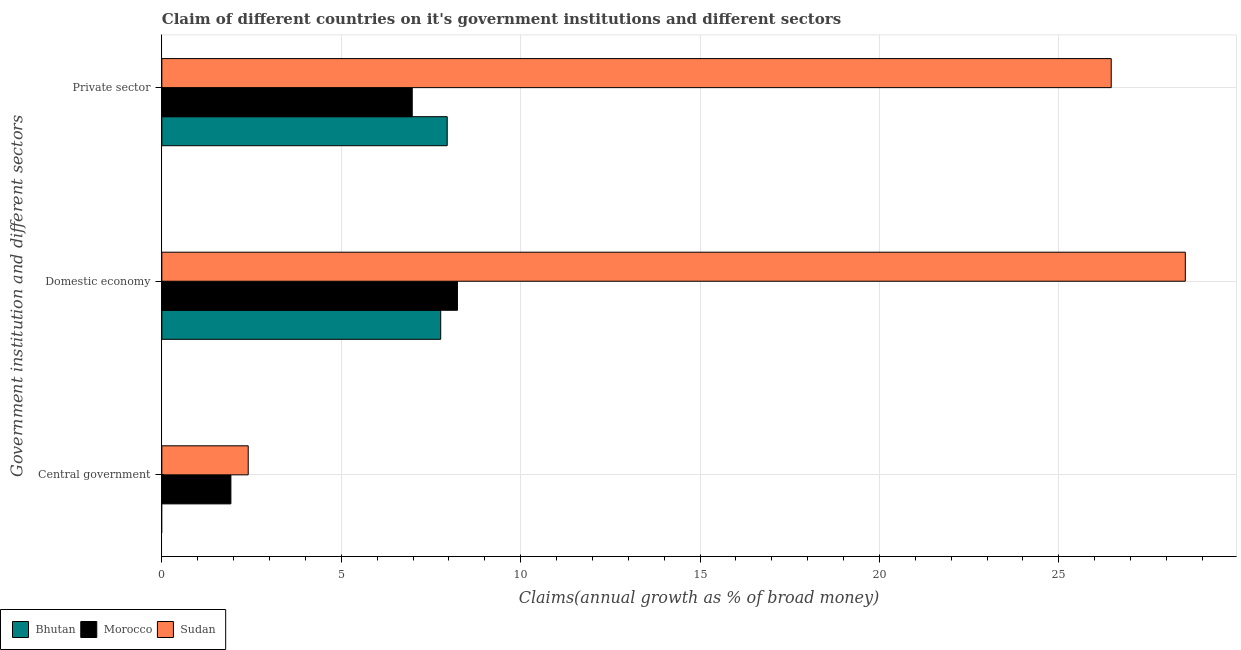Are the number of bars per tick equal to the number of legend labels?
Make the answer very short. No. How many bars are there on the 1st tick from the top?
Keep it short and to the point. 3. What is the label of the 3rd group of bars from the top?
Provide a short and direct response. Central government. What is the percentage of claim on the domestic economy in Morocco?
Provide a succinct answer. 8.24. Across all countries, what is the maximum percentage of claim on the private sector?
Keep it short and to the point. 26.46. Across all countries, what is the minimum percentage of claim on the central government?
Provide a succinct answer. 0. In which country was the percentage of claim on the central government maximum?
Make the answer very short. Sudan. What is the total percentage of claim on the domestic economy in the graph?
Offer a terse response. 44.54. What is the difference between the percentage of claim on the domestic economy in Bhutan and that in Sudan?
Keep it short and to the point. -20.75. What is the difference between the percentage of claim on the central government in Bhutan and the percentage of claim on the domestic economy in Sudan?
Ensure brevity in your answer.  -28.52. What is the average percentage of claim on the central government per country?
Your answer should be very brief. 1.44. What is the difference between the percentage of claim on the private sector and percentage of claim on the domestic economy in Bhutan?
Make the answer very short. 0.18. What is the ratio of the percentage of claim on the central government in Sudan to that in Morocco?
Provide a short and direct response. 1.25. Is the difference between the percentage of claim on the central government in Morocco and Sudan greater than the difference between the percentage of claim on the domestic economy in Morocco and Sudan?
Provide a short and direct response. Yes. What is the difference between the highest and the second highest percentage of claim on the private sector?
Provide a short and direct response. 18.51. What is the difference between the highest and the lowest percentage of claim on the private sector?
Make the answer very short. 19.48. Is the sum of the percentage of claim on the private sector in Sudan and Morocco greater than the maximum percentage of claim on the central government across all countries?
Provide a short and direct response. Yes. Is it the case that in every country, the sum of the percentage of claim on the central government and percentage of claim on the domestic economy is greater than the percentage of claim on the private sector?
Ensure brevity in your answer.  No. How many bars are there?
Your answer should be compact. 8. Are all the bars in the graph horizontal?
Your answer should be compact. Yes. Does the graph contain any zero values?
Make the answer very short. Yes. Where does the legend appear in the graph?
Keep it short and to the point. Bottom left. How many legend labels are there?
Your answer should be very brief. 3. What is the title of the graph?
Offer a very short reply. Claim of different countries on it's government institutions and different sectors. What is the label or title of the X-axis?
Provide a succinct answer. Claims(annual growth as % of broad money). What is the label or title of the Y-axis?
Keep it short and to the point. Government institution and different sectors. What is the Claims(annual growth as % of broad money) in Bhutan in Central government?
Your answer should be very brief. 0. What is the Claims(annual growth as % of broad money) of Morocco in Central government?
Keep it short and to the point. 1.92. What is the Claims(annual growth as % of broad money) in Sudan in Central government?
Keep it short and to the point. 2.41. What is the Claims(annual growth as % of broad money) in Bhutan in Domestic economy?
Your answer should be very brief. 7.77. What is the Claims(annual growth as % of broad money) in Morocco in Domestic economy?
Your response must be concise. 8.24. What is the Claims(annual growth as % of broad money) in Sudan in Domestic economy?
Offer a terse response. 28.52. What is the Claims(annual growth as % of broad money) of Bhutan in Private sector?
Your answer should be very brief. 7.95. What is the Claims(annual growth as % of broad money) in Morocco in Private sector?
Your answer should be very brief. 6.98. What is the Claims(annual growth as % of broad money) in Sudan in Private sector?
Make the answer very short. 26.46. Across all Government institution and different sectors, what is the maximum Claims(annual growth as % of broad money) of Bhutan?
Your answer should be very brief. 7.95. Across all Government institution and different sectors, what is the maximum Claims(annual growth as % of broad money) of Morocco?
Your answer should be very brief. 8.24. Across all Government institution and different sectors, what is the maximum Claims(annual growth as % of broad money) of Sudan?
Keep it short and to the point. 28.52. Across all Government institution and different sectors, what is the minimum Claims(annual growth as % of broad money) of Morocco?
Provide a short and direct response. 1.92. Across all Government institution and different sectors, what is the minimum Claims(annual growth as % of broad money) of Sudan?
Give a very brief answer. 2.41. What is the total Claims(annual growth as % of broad money) in Bhutan in the graph?
Your answer should be compact. 15.73. What is the total Claims(annual growth as % of broad money) in Morocco in the graph?
Make the answer very short. 17.14. What is the total Claims(annual growth as % of broad money) of Sudan in the graph?
Your answer should be very brief. 57.39. What is the difference between the Claims(annual growth as % of broad money) in Morocco in Central government and that in Domestic economy?
Provide a succinct answer. -6.31. What is the difference between the Claims(annual growth as % of broad money) in Sudan in Central government and that in Domestic economy?
Give a very brief answer. -26.12. What is the difference between the Claims(annual growth as % of broad money) of Morocco in Central government and that in Private sector?
Offer a terse response. -5.05. What is the difference between the Claims(annual growth as % of broad money) in Sudan in Central government and that in Private sector?
Offer a very short reply. -24.05. What is the difference between the Claims(annual growth as % of broad money) in Bhutan in Domestic economy and that in Private sector?
Provide a short and direct response. -0.18. What is the difference between the Claims(annual growth as % of broad money) of Morocco in Domestic economy and that in Private sector?
Provide a short and direct response. 1.26. What is the difference between the Claims(annual growth as % of broad money) in Sudan in Domestic economy and that in Private sector?
Offer a terse response. 2.06. What is the difference between the Claims(annual growth as % of broad money) of Morocco in Central government and the Claims(annual growth as % of broad money) of Sudan in Domestic economy?
Provide a short and direct response. -26.6. What is the difference between the Claims(annual growth as % of broad money) in Morocco in Central government and the Claims(annual growth as % of broad money) in Sudan in Private sector?
Make the answer very short. -24.53. What is the difference between the Claims(annual growth as % of broad money) of Bhutan in Domestic economy and the Claims(annual growth as % of broad money) of Morocco in Private sector?
Offer a terse response. 0.79. What is the difference between the Claims(annual growth as % of broad money) in Bhutan in Domestic economy and the Claims(annual growth as % of broad money) in Sudan in Private sector?
Ensure brevity in your answer.  -18.69. What is the difference between the Claims(annual growth as % of broad money) of Morocco in Domestic economy and the Claims(annual growth as % of broad money) of Sudan in Private sector?
Your answer should be compact. -18.22. What is the average Claims(annual growth as % of broad money) of Bhutan per Government institution and different sectors?
Keep it short and to the point. 5.24. What is the average Claims(annual growth as % of broad money) of Morocco per Government institution and different sectors?
Provide a short and direct response. 5.71. What is the average Claims(annual growth as % of broad money) in Sudan per Government institution and different sectors?
Your answer should be compact. 19.13. What is the difference between the Claims(annual growth as % of broad money) of Morocco and Claims(annual growth as % of broad money) of Sudan in Central government?
Offer a very short reply. -0.48. What is the difference between the Claims(annual growth as % of broad money) of Bhutan and Claims(annual growth as % of broad money) of Morocco in Domestic economy?
Your response must be concise. -0.47. What is the difference between the Claims(annual growth as % of broad money) of Bhutan and Claims(annual growth as % of broad money) of Sudan in Domestic economy?
Ensure brevity in your answer.  -20.75. What is the difference between the Claims(annual growth as % of broad money) in Morocco and Claims(annual growth as % of broad money) in Sudan in Domestic economy?
Your answer should be compact. -20.29. What is the difference between the Claims(annual growth as % of broad money) in Bhutan and Claims(annual growth as % of broad money) in Morocco in Private sector?
Keep it short and to the point. 0.97. What is the difference between the Claims(annual growth as % of broad money) of Bhutan and Claims(annual growth as % of broad money) of Sudan in Private sector?
Make the answer very short. -18.51. What is the difference between the Claims(annual growth as % of broad money) in Morocco and Claims(annual growth as % of broad money) in Sudan in Private sector?
Your response must be concise. -19.48. What is the ratio of the Claims(annual growth as % of broad money) in Morocco in Central government to that in Domestic economy?
Give a very brief answer. 0.23. What is the ratio of the Claims(annual growth as % of broad money) of Sudan in Central government to that in Domestic economy?
Provide a short and direct response. 0.08. What is the ratio of the Claims(annual growth as % of broad money) in Morocco in Central government to that in Private sector?
Your response must be concise. 0.28. What is the ratio of the Claims(annual growth as % of broad money) in Sudan in Central government to that in Private sector?
Offer a terse response. 0.09. What is the ratio of the Claims(annual growth as % of broad money) of Bhutan in Domestic economy to that in Private sector?
Give a very brief answer. 0.98. What is the ratio of the Claims(annual growth as % of broad money) of Morocco in Domestic economy to that in Private sector?
Make the answer very short. 1.18. What is the ratio of the Claims(annual growth as % of broad money) of Sudan in Domestic economy to that in Private sector?
Offer a very short reply. 1.08. What is the difference between the highest and the second highest Claims(annual growth as % of broad money) of Morocco?
Give a very brief answer. 1.26. What is the difference between the highest and the second highest Claims(annual growth as % of broad money) in Sudan?
Make the answer very short. 2.06. What is the difference between the highest and the lowest Claims(annual growth as % of broad money) in Bhutan?
Offer a terse response. 7.95. What is the difference between the highest and the lowest Claims(annual growth as % of broad money) of Morocco?
Provide a short and direct response. 6.31. What is the difference between the highest and the lowest Claims(annual growth as % of broad money) of Sudan?
Ensure brevity in your answer.  26.12. 